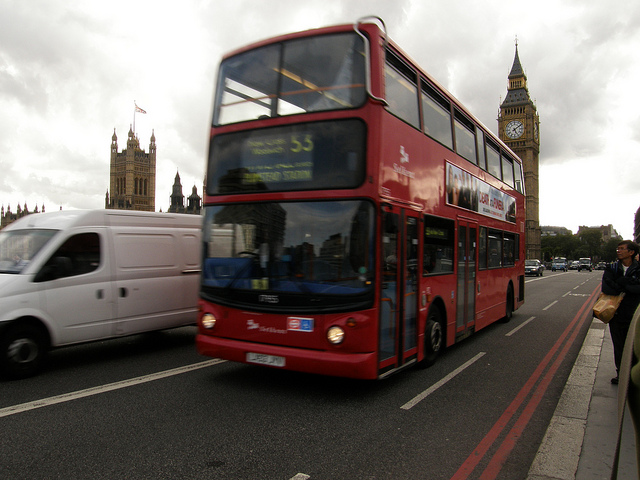Identify the text contained in this image. 53 